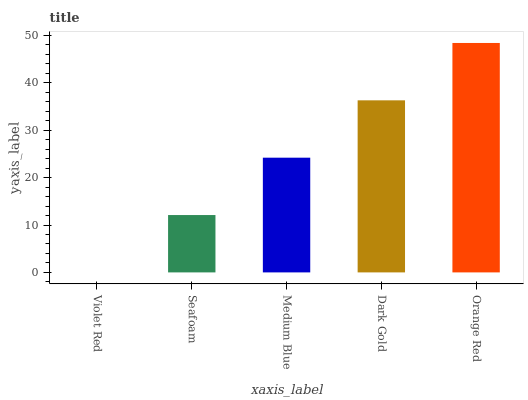Is Violet Red the minimum?
Answer yes or no. Yes. Is Orange Red the maximum?
Answer yes or no. Yes. Is Seafoam the minimum?
Answer yes or no. No. Is Seafoam the maximum?
Answer yes or no. No. Is Seafoam greater than Violet Red?
Answer yes or no. Yes. Is Violet Red less than Seafoam?
Answer yes or no. Yes. Is Violet Red greater than Seafoam?
Answer yes or no. No. Is Seafoam less than Violet Red?
Answer yes or no. No. Is Medium Blue the high median?
Answer yes or no. Yes. Is Medium Blue the low median?
Answer yes or no. Yes. Is Orange Red the high median?
Answer yes or no. No. Is Seafoam the low median?
Answer yes or no. No. 